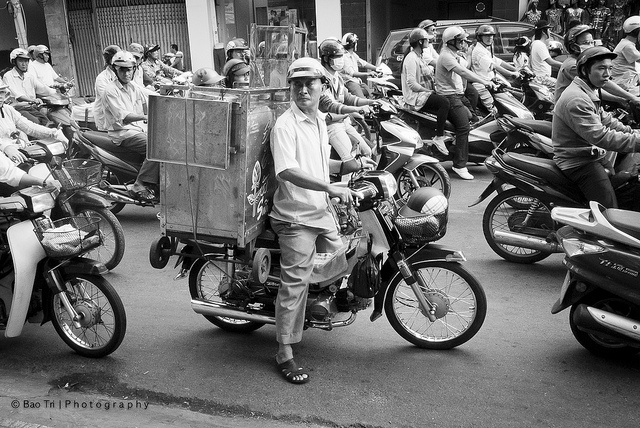Describe the objects in this image and their specific colors. I can see motorcycle in black, darkgray, gray, and lightgray tones, motorcycle in black, darkgray, gray, and lightgray tones, people in black, lightgray, gray, and darkgray tones, motorcycle in black, darkgray, gray, and lightgray tones, and people in black, lightgray, darkgray, and gray tones in this image. 